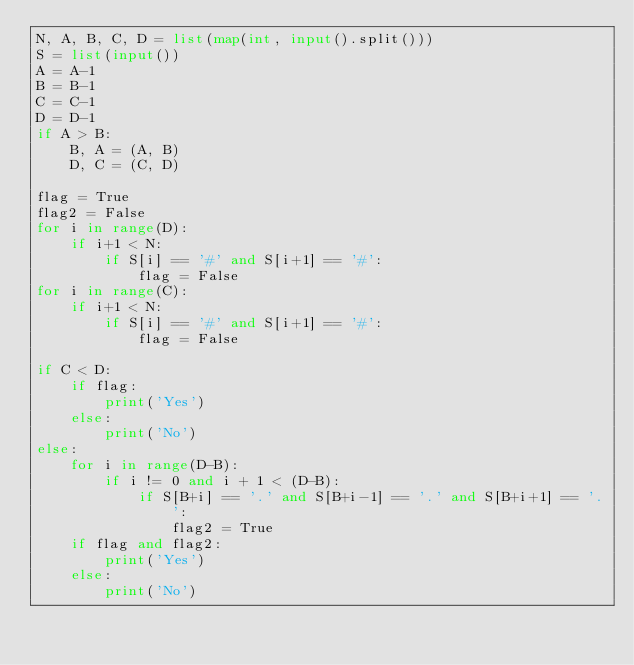<code> <loc_0><loc_0><loc_500><loc_500><_Python_>N, A, B, C, D = list(map(int, input().split()))
S = list(input())
A = A-1
B = B-1
C = C-1
D = D-1
if A > B:
    B, A = (A, B)
    D, C = (C, D)

flag = True
flag2 = False
for i in range(D):
    if i+1 < N:
        if S[i] == '#' and S[i+1] == '#':
            flag = False
for i in range(C):
    if i+1 < N:
        if S[i] == '#' and S[i+1] == '#':
            flag = False

if C < D:
    if flag:
        print('Yes')
    else:
        print('No')
else:
    for i in range(D-B):
        if i != 0 and i + 1 < (D-B):
            if S[B+i] == '.' and S[B+i-1] == '.' and S[B+i+1] == '.':
                flag2 = True
    if flag and flag2:
        print('Yes')
    else:
        print('No')</code> 